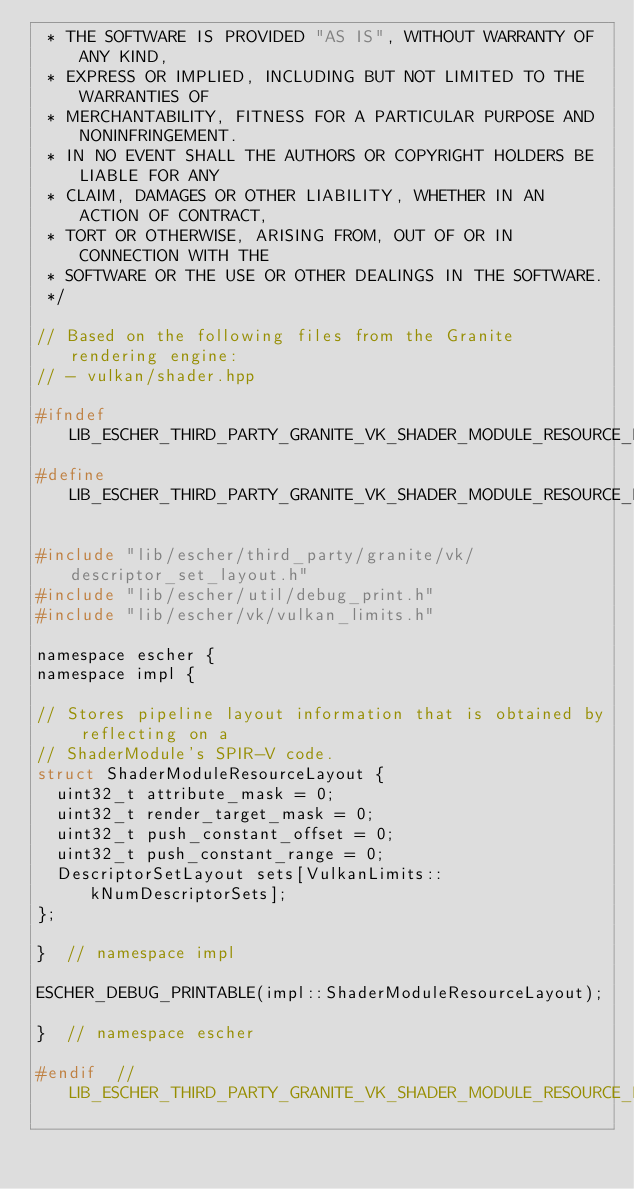<code> <loc_0><loc_0><loc_500><loc_500><_C_> * THE SOFTWARE IS PROVIDED "AS IS", WITHOUT WARRANTY OF ANY KIND,
 * EXPRESS OR IMPLIED, INCLUDING BUT NOT LIMITED TO THE WARRANTIES OF
 * MERCHANTABILITY, FITNESS FOR A PARTICULAR PURPOSE AND NONINFRINGEMENT.
 * IN NO EVENT SHALL THE AUTHORS OR COPYRIGHT HOLDERS BE LIABLE FOR ANY
 * CLAIM, DAMAGES OR OTHER LIABILITY, WHETHER IN AN ACTION OF CONTRACT,
 * TORT OR OTHERWISE, ARISING FROM, OUT OF OR IN CONNECTION WITH THE
 * SOFTWARE OR THE USE OR OTHER DEALINGS IN THE SOFTWARE.
 */

// Based on the following files from the Granite rendering engine:
// - vulkan/shader.hpp

#ifndef LIB_ESCHER_THIRD_PARTY_GRANITE_VK_SHADER_MODULE_RESOURCE_LAYOUT_H_
#define LIB_ESCHER_THIRD_PARTY_GRANITE_VK_SHADER_MODULE_RESOURCE_LAYOUT_H_

#include "lib/escher/third_party/granite/vk/descriptor_set_layout.h"
#include "lib/escher/util/debug_print.h"
#include "lib/escher/vk/vulkan_limits.h"

namespace escher {
namespace impl {

// Stores pipeline layout information that is obtained by reflecting on a
// ShaderModule's SPIR-V code.
struct ShaderModuleResourceLayout {
  uint32_t attribute_mask = 0;
  uint32_t render_target_mask = 0;
  uint32_t push_constant_offset = 0;
  uint32_t push_constant_range = 0;
  DescriptorSetLayout sets[VulkanLimits::kNumDescriptorSets];
};

}  // namespace impl

ESCHER_DEBUG_PRINTABLE(impl::ShaderModuleResourceLayout);

}  // namespace escher

#endif  // LIB_ESCHER_THIRD_PARTY_GRANITE_VK_SHADER_MODULE_RESOURCE_LAYOUT_H_
</code> 